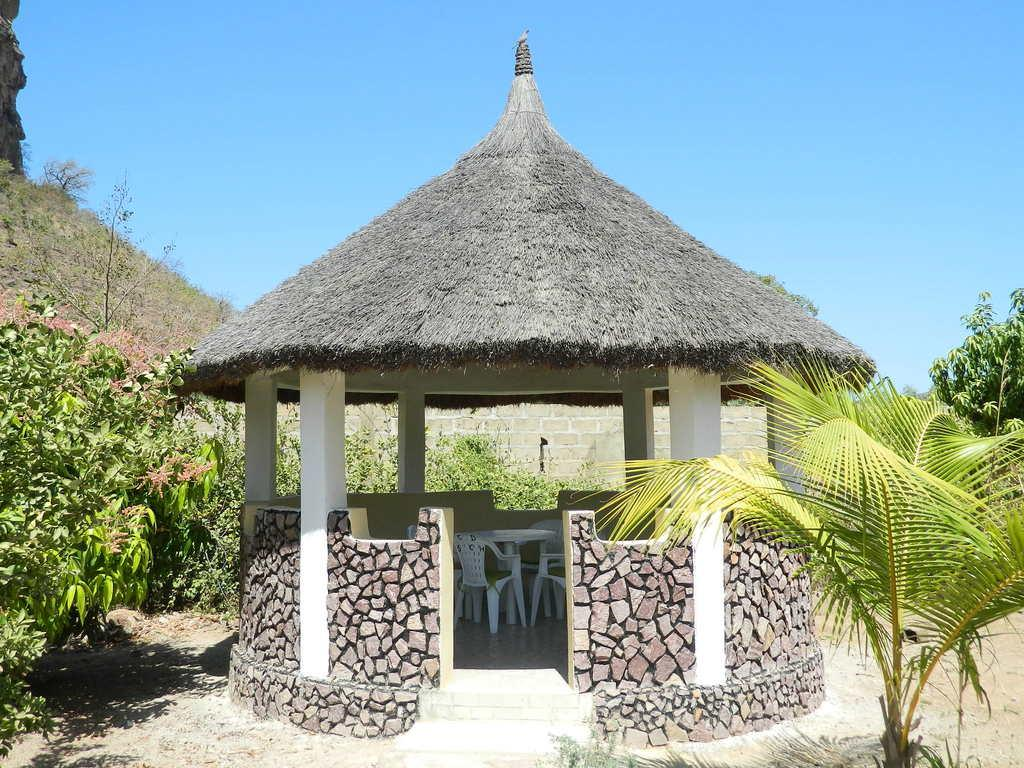What type of house is shown in the image? There is a thatched house in the image. What furniture can be seen inside the house? There are chairs inside the house. What can be seen in the background of the image? There are trees and hills in the background of the image. What is visible on the ground in the image? The ground is visible in the image. What part of the natural environment is visible above the ground? The sky is visible in the image. Can you tell me how many cats are exchanging monkeys in the image? There are no cats or monkeys present in the image, so this exchange cannot be observed. 